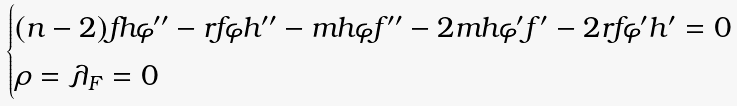<formula> <loc_0><loc_0><loc_500><loc_500>\begin{cases} ( n - 2 ) f h \varphi ^ { \prime \prime } - r f \varphi h ^ { \prime \prime } - m h \varphi f ^ { \prime \prime } - 2 m h \varphi ^ { \prime } f ^ { \prime } - 2 r f \varphi ^ { \prime } h ^ { \prime } = 0 \\ \rho = \lambda _ { F } = 0 \\ \end{cases}</formula> 